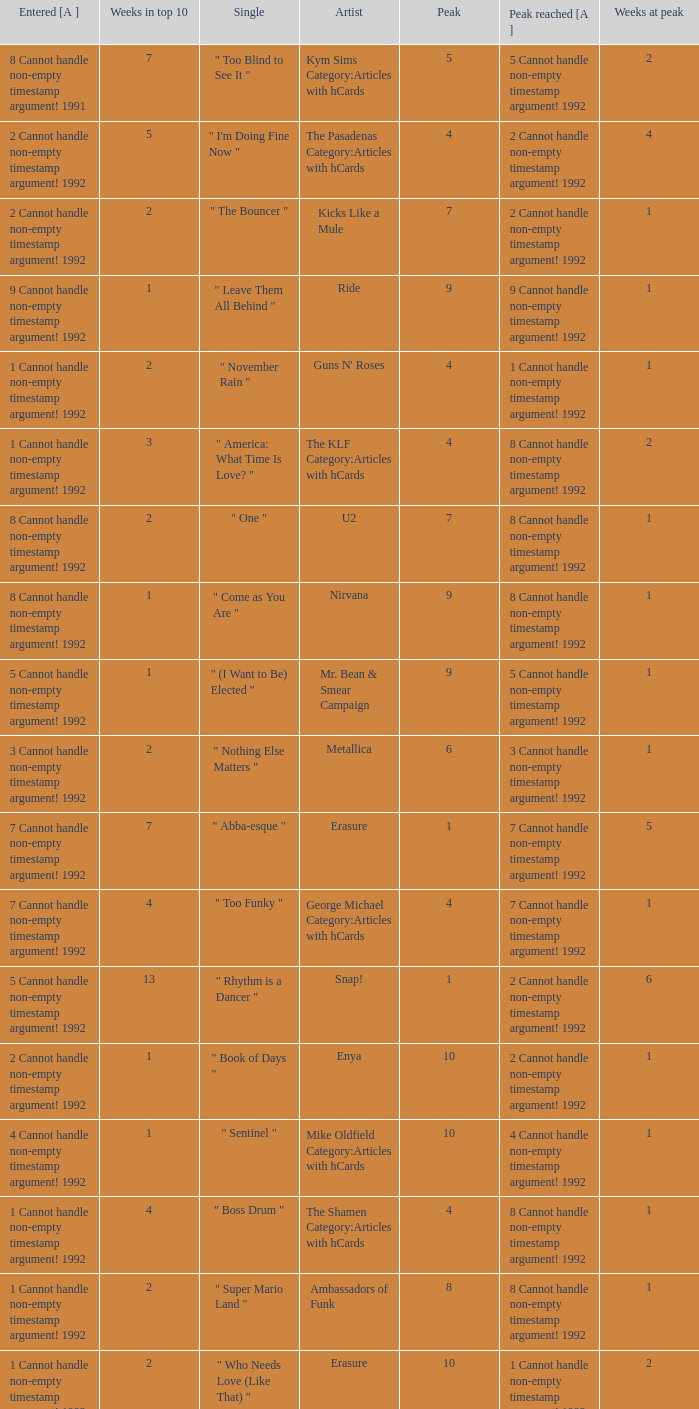When the highest position was 9, for how many weeks did it stay in the top 10? 1.0. Give me the full table as a dictionary. {'header': ['Entered [A ]', 'Weeks in top 10', 'Single', 'Artist', 'Peak', 'Peak reached [A ]', 'Weeks at peak'], 'rows': [['8 Cannot handle non-empty timestamp argument! 1991', '7', '" Too Blind to See It "', 'Kym Sims Category:Articles with hCards', '5', '5 Cannot handle non-empty timestamp argument! 1992', '2'], ['2 Cannot handle non-empty timestamp argument! 1992', '5', '" I\'m Doing Fine Now "', 'The Pasadenas Category:Articles with hCards', '4', '2 Cannot handle non-empty timestamp argument! 1992', '4'], ['2 Cannot handle non-empty timestamp argument! 1992', '2', '" The Bouncer "', 'Kicks Like a Mule', '7', '2 Cannot handle non-empty timestamp argument! 1992', '1'], ['9 Cannot handle non-empty timestamp argument! 1992', '1', '" Leave Them All Behind "', 'Ride', '9', '9 Cannot handle non-empty timestamp argument! 1992', '1'], ['1 Cannot handle non-empty timestamp argument! 1992', '2', '" November Rain "', "Guns N' Roses", '4', '1 Cannot handle non-empty timestamp argument! 1992', '1'], ['1 Cannot handle non-empty timestamp argument! 1992', '3', '" America: What Time Is Love? "', 'The KLF Category:Articles with hCards', '4', '8 Cannot handle non-empty timestamp argument! 1992', '2'], ['8 Cannot handle non-empty timestamp argument! 1992', '2', '" One "', 'U2', '7', '8 Cannot handle non-empty timestamp argument! 1992', '1'], ['8 Cannot handle non-empty timestamp argument! 1992', '1', '" Come as You Are "', 'Nirvana', '9', '8 Cannot handle non-empty timestamp argument! 1992', '1'], ['5 Cannot handle non-empty timestamp argument! 1992', '1', '" (I Want to Be) Elected "', 'Mr. Bean & Smear Campaign', '9', '5 Cannot handle non-empty timestamp argument! 1992', '1'], ['3 Cannot handle non-empty timestamp argument! 1992', '2', '" Nothing Else Matters "', 'Metallica', '6', '3 Cannot handle non-empty timestamp argument! 1992', '1'], ['7 Cannot handle non-empty timestamp argument! 1992', '7', '" Abba-esque "', 'Erasure', '1', '7 Cannot handle non-empty timestamp argument! 1992', '5'], ['7 Cannot handle non-empty timestamp argument! 1992', '4', '" Too Funky "', 'George Michael Category:Articles with hCards', '4', '7 Cannot handle non-empty timestamp argument! 1992', '1'], ['5 Cannot handle non-empty timestamp argument! 1992', '13', '" Rhythm is a Dancer "', 'Snap!', '1', '2 Cannot handle non-empty timestamp argument! 1992', '6'], ['2 Cannot handle non-empty timestamp argument! 1992', '1', '" Book of Days "', 'Enya', '10', '2 Cannot handle non-empty timestamp argument! 1992', '1'], ['4 Cannot handle non-empty timestamp argument! 1992', '1', '" Sentinel "', 'Mike Oldfield Category:Articles with hCards', '10', '4 Cannot handle non-empty timestamp argument! 1992', '1'], ['1 Cannot handle non-empty timestamp argument! 1992', '4', '" Boss Drum "', 'The Shamen Category:Articles with hCards', '4', '8 Cannot handle non-empty timestamp argument! 1992', '1'], ['1 Cannot handle non-empty timestamp argument! 1992', '2', '" Super Mario Land "', 'Ambassadors of Funk', '8', '8 Cannot handle non-empty timestamp argument! 1992', '1'], ['1 Cannot handle non-empty timestamp argument! 1992', '2', '" Who Needs Love (Like That) "', 'Erasure', '10', '1 Cannot handle non-empty timestamp argument! 1992', '2'], ['8 Cannot handle non-empty timestamp argument! 1992', '2', '" Be My Baby "', 'Vanessa Paradis Category:Articles with hCards', '6', '8 Cannot handle non-empty timestamp argument! 1992', '1'], ['6 Cannot handle non-empty timestamp argument! 1992', '5', '" Slam Jam "', 'WWF Superstars', '4', '6 Cannot handle non-empty timestamp argument! 1992', '2']]} 